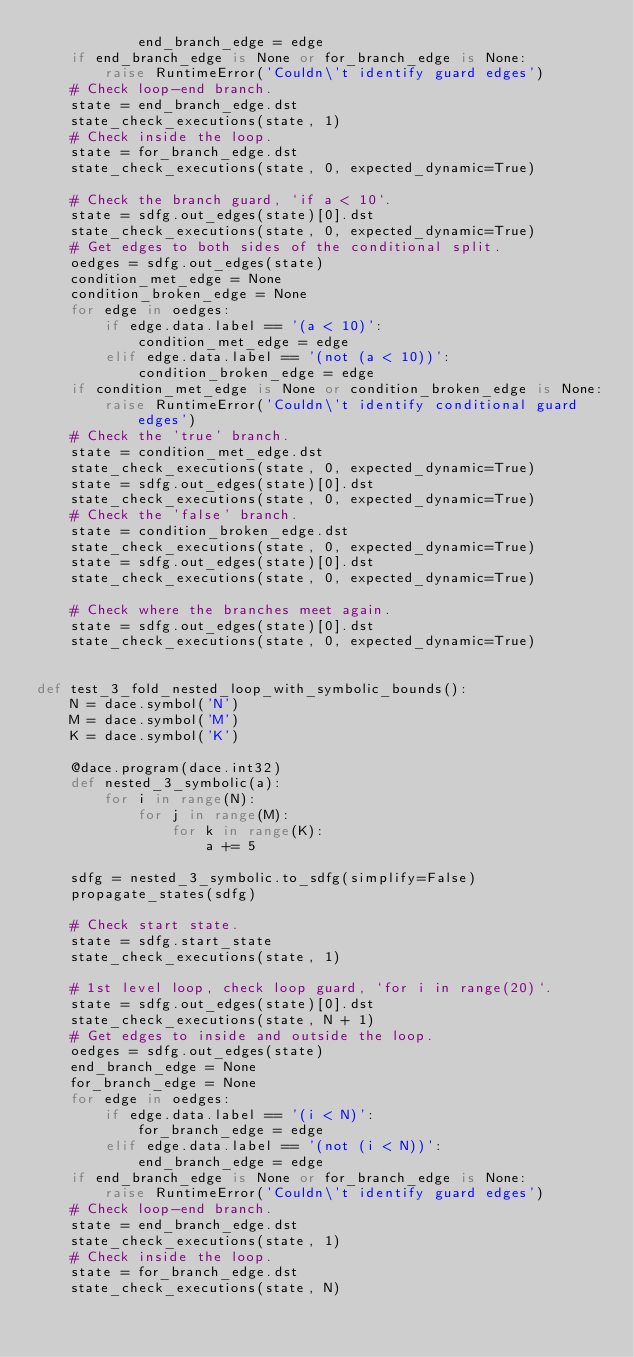<code> <loc_0><loc_0><loc_500><loc_500><_Python_>            end_branch_edge = edge
    if end_branch_edge is None or for_branch_edge is None:
        raise RuntimeError('Couldn\'t identify guard edges')
    # Check loop-end branch.
    state = end_branch_edge.dst
    state_check_executions(state, 1)
    # Check inside the loop.
    state = for_branch_edge.dst
    state_check_executions(state, 0, expected_dynamic=True)

    # Check the branch guard, `if a < 10`.
    state = sdfg.out_edges(state)[0].dst
    state_check_executions(state, 0, expected_dynamic=True)
    # Get edges to both sides of the conditional split.
    oedges = sdfg.out_edges(state)
    condition_met_edge = None
    condition_broken_edge = None
    for edge in oedges:
        if edge.data.label == '(a < 10)':
            condition_met_edge = edge
        elif edge.data.label == '(not (a < 10))':
            condition_broken_edge = edge
    if condition_met_edge is None or condition_broken_edge is None:
        raise RuntimeError('Couldn\'t identify conditional guard edges')
    # Check the 'true' branch.
    state = condition_met_edge.dst
    state_check_executions(state, 0, expected_dynamic=True)
    state = sdfg.out_edges(state)[0].dst
    state_check_executions(state, 0, expected_dynamic=True)
    # Check the 'false' branch.
    state = condition_broken_edge.dst
    state_check_executions(state, 0, expected_dynamic=True)
    state = sdfg.out_edges(state)[0].dst
    state_check_executions(state, 0, expected_dynamic=True)

    # Check where the branches meet again.
    state = sdfg.out_edges(state)[0].dst
    state_check_executions(state, 0, expected_dynamic=True)


def test_3_fold_nested_loop_with_symbolic_bounds():
    N = dace.symbol('N')
    M = dace.symbol('M')
    K = dace.symbol('K')

    @dace.program(dace.int32)
    def nested_3_symbolic(a):
        for i in range(N):
            for j in range(M):
                for k in range(K):
                    a += 5

    sdfg = nested_3_symbolic.to_sdfg(simplify=False)
    propagate_states(sdfg)

    # Check start state.
    state = sdfg.start_state
    state_check_executions(state, 1)

    # 1st level loop, check loop guard, `for i in range(20)`.
    state = sdfg.out_edges(state)[0].dst
    state_check_executions(state, N + 1)
    # Get edges to inside and outside the loop.
    oedges = sdfg.out_edges(state)
    end_branch_edge = None
    for_branch_edge = None
    for edge in oedges:
        if edge.data.label == '(i < N)':
            for_branch_edge = edge
        elif edge.data.label == '(not (i < N))':
            end_branch_edge = edge
    if end_branch_edge is None or for_branch_edge is None:
        raise RuntimeError('Couldn\'t identify guard edges')
    # Check loop-end branch.
    state = end_branch_edge.dst
    state_check_executions(state, 1)
    # Check inside the loop.
    state = for_branch_edge.dst
    state_check_executions(state, N)
</code> 